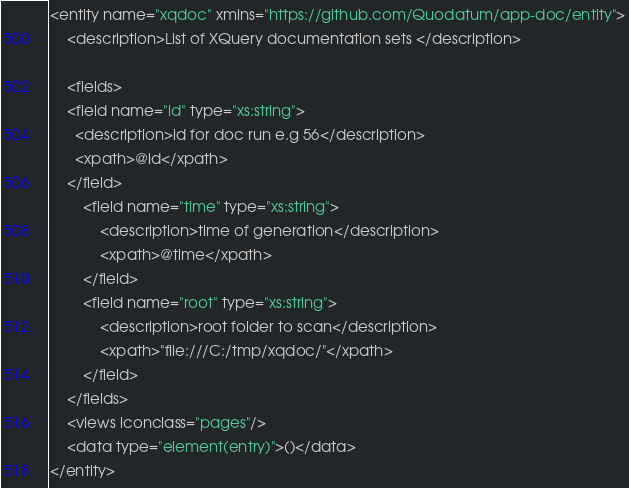Convert code to text. <code><loc_0><loc_0><loc_500><loc_500><_XML_><entity name="xqdoc" xmlns="https://github.com/Quodatum/app-doc/entity">
	<description>List of XQuery documentation sets </description>

	<fields>
	<field name="id" type="xs:string">
      <description>id for doc run e.g 56</description>
      <xpath>@id</xpath>
    </field>
		<field name="time" type="xs:string">
			<description>time of generation</description>
			<xpath>@time</xpath>
		</field>
		<field name="root" type="xs:string">
			<description>root folder to scan</description>
			<xpath>"file:///C:/tmp/xqdoc/"</xpath>
		</field>
	</fields>
	<views iconclass="pages"/>
	<data type="element(entry)">()</data>
</entity></code> 